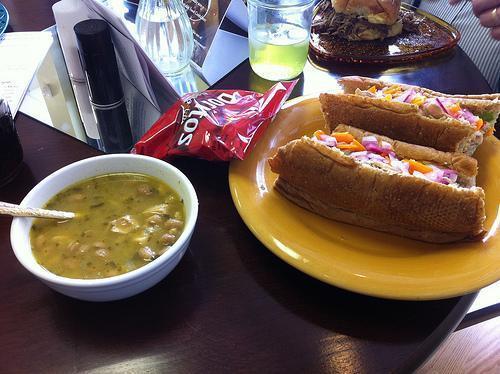How many bowls are in the picture?
Give a very brief answer. 1. How many dinosaurs are in the picture?
Give a very brief answer. 0. 